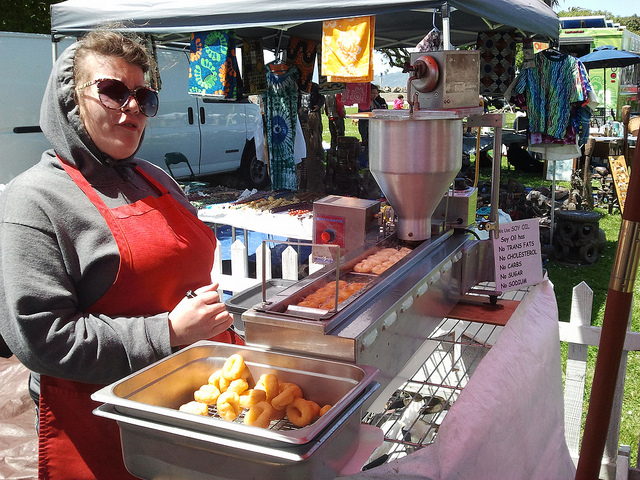Please transcribe the text information in this image. SOY Of has No SUGAR NO NO CHOLESTEROL NO FATS TRANS NO 